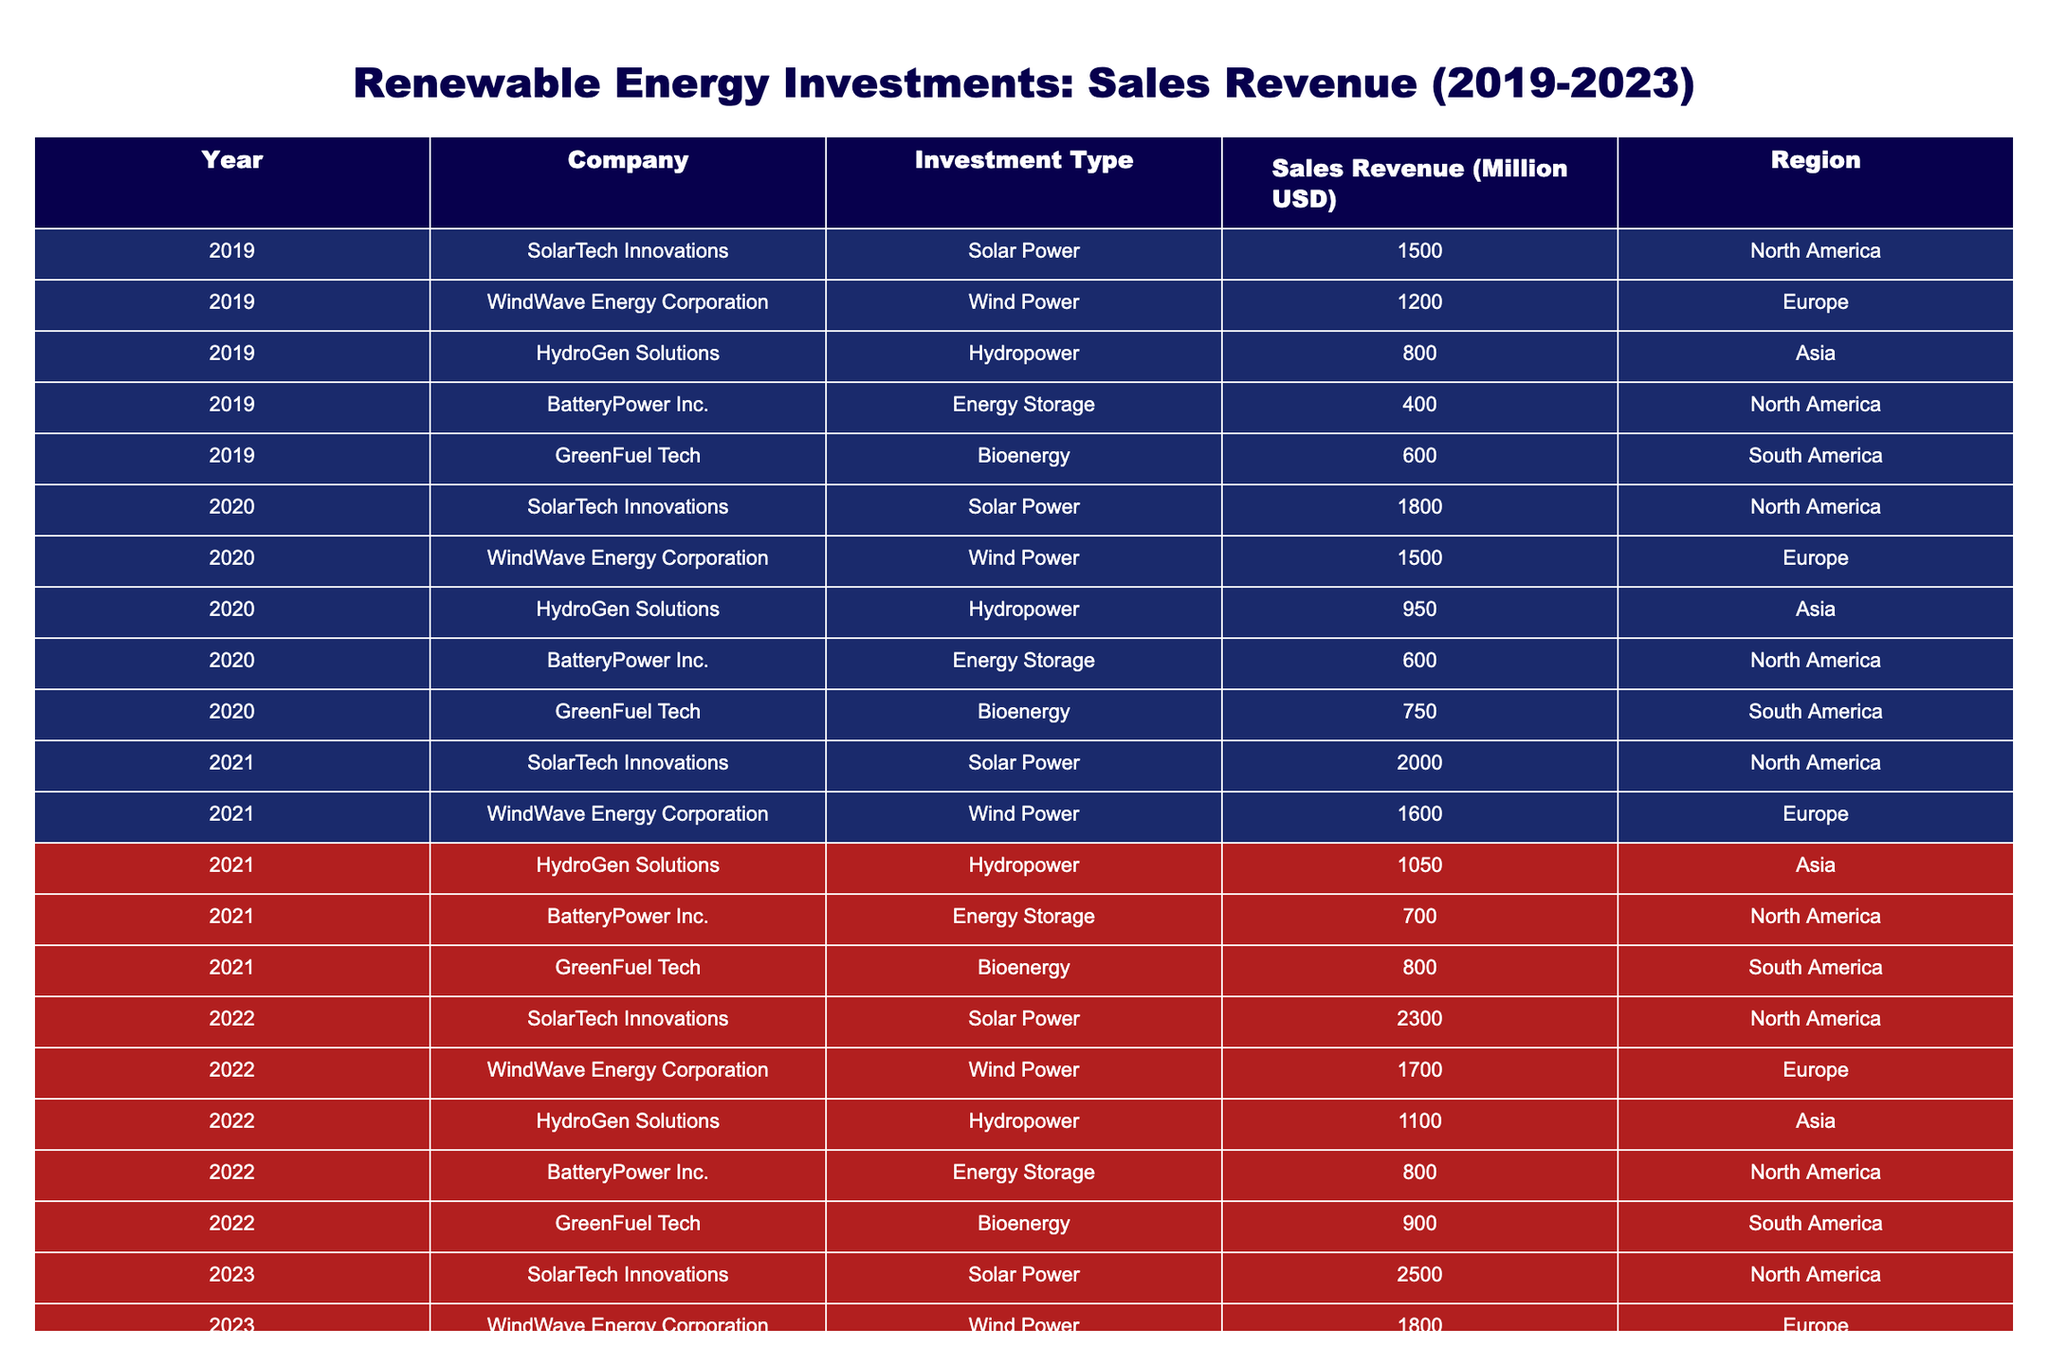What was the sales revenue for SolarTech Innovations in 2021? In 2021, we look at the row for SolarTech Innovations and find the corresponding sales revenue, which is 2000 million USD.
Answer: 2000 million USD Which company had the highest sales revenue in 2022? By examining the sales revenue values for each company in 2022, SolarTech Innovations led with 2300 million USD, more than any other company.
Answer: SolarTech Innovations What is the total sales revenue from Wind Power across all years? To find the total sales revenue from Wind Power, we add the sales revenues for WindWave Energy Corporation from each year: 1200 + 1500 + 1600 + 1700 + 1800 = 8000 million USD.
Answer: 8000 million USD Is the sales revenue from Energy Storage increasing every year? Checking the sales revenues for BatteryPower Inc. (Energy Storage), we find the revenues for the years are: 400, 600, 700, 800, 900 million USD. Since this shows a consistent increase each year, the statement is true.
Answer: Yes What was the average sales revenue from Hydropower over the five years? We identify the sales revenues from HydroGen Solutions for each year: 800, 950, 1050, 1100, 1150. Adding these gives us 5050 million USD, and dividing by 5 (the number of years) results in an average of 1010 million USD.
Answer: 1010 million USD Which region had the lowest total sales revenue from renewable energy investments over the five years? By calculating total sales revenue for each region: North America: 1500 + 1800 + 2000 + 2300 + 2500 = 11100; Europe: 1200 + 1500 + 1600 + 1700 + 1800 = 8000; Asia: 800 + 950 + 1050 + 1100 + 1150 = 4050; South America: 600 + 750 + 800 + 900 + 950 = 4000. South America has the lowest total sales revenue of 4000 million USD.
Answer: South America Was the growth rate of sales revenue from Bioenergy higher than that of Solar Power from 2019 to 2023? For Bioenergy, the sales revenue increased from 600 to 950, so the growth rate is (950-600)/600 = 0.5833, or 58.33%. For Solar Power, the revenue raised from 1500 to 2500, leading to a growth rate of (2500-1500)/1500 = 0.6667, or 66.67%. Since 66.67% is greater than 58.33%, the statement is false.
Answer: No What was the difference in sales revenue between the highest and lowest-performing investment type in 2023? In 2023, the highest sales revenue was from Solar Power at 2500 million USD, while the lowest was from Energy Storage at 900 million USD. Calculating the difference gives us 2500 - 900 = 1600 million USD.
Answer: 1600 million USD What patterns can be observed in the sales revenue trends from 2019 to 2023? By examining the data, it is evident that all companies generally experience an upward trend in their sales revenue over the years, with noticeable growth milestones, particularly for Solar Power investments, indicating a growing market in renewable energy investments.
Answer: Upward trend in all investments 